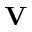<formula> <loc_0><loc_0><loc_500><loc_500>V</formula> 